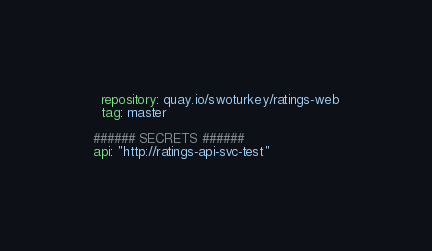Convert code to text. <code><loc_0><loc_0><loc_500><loc_500><_YAML_>  repository: quay.io/swoturkey/ratings-web
  tag: master

###### SECRETS ######
api: "http://ratings-api-svc-test"
</code> 